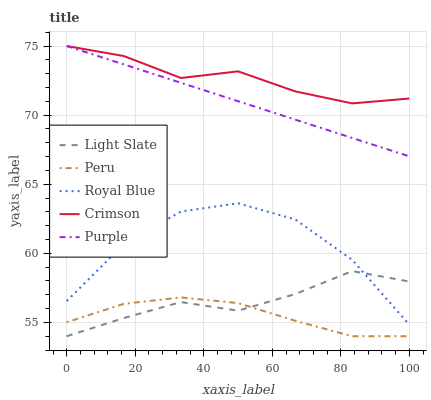Does Peru have the minimum area under the curve?
Answer yes or no. Yes. Does Crimson have the maximum area under the curve?
Answer yes or no. Yes. Does Royal Blue have the minimum area under the curve?
Answer yes or no. No. Does Royal Blue have the maximum area under the curve?
Answer yes or no. No. Is Purple the smoothest?
Answer yes or no. Yes. Is Royal Blue the roughest?
Answer yes or no. Yes. Is Royal Blue the smoothest?
Answer yes or no. No. Is Purple the roughest?
Answer yes or no. No. Does Royal Blue have the lowest value?
Answer yes or no. No. Does Royal Blue have the highest value?
Answer yes or no. No. Is Light Slate less than Crimson?
Answer yes or no. Yes. Is Crimson greater than Royal Blue?
Answer yes or no. Yes. Does Light Slate intersect Crimson?
Answer yes or no. No. 